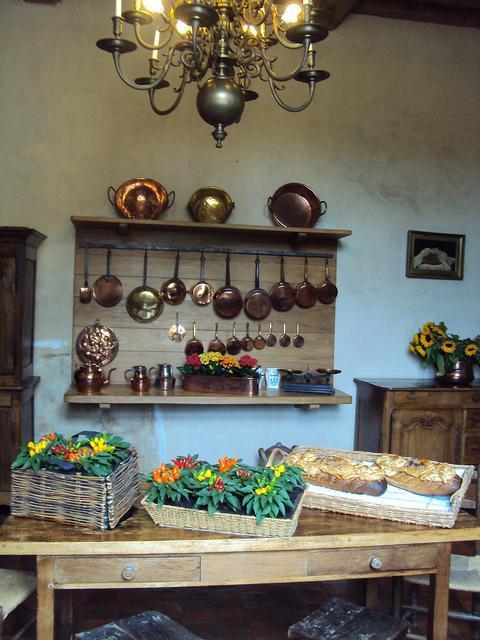How many potted plants can you see?
Give a very brief answer. 4. 